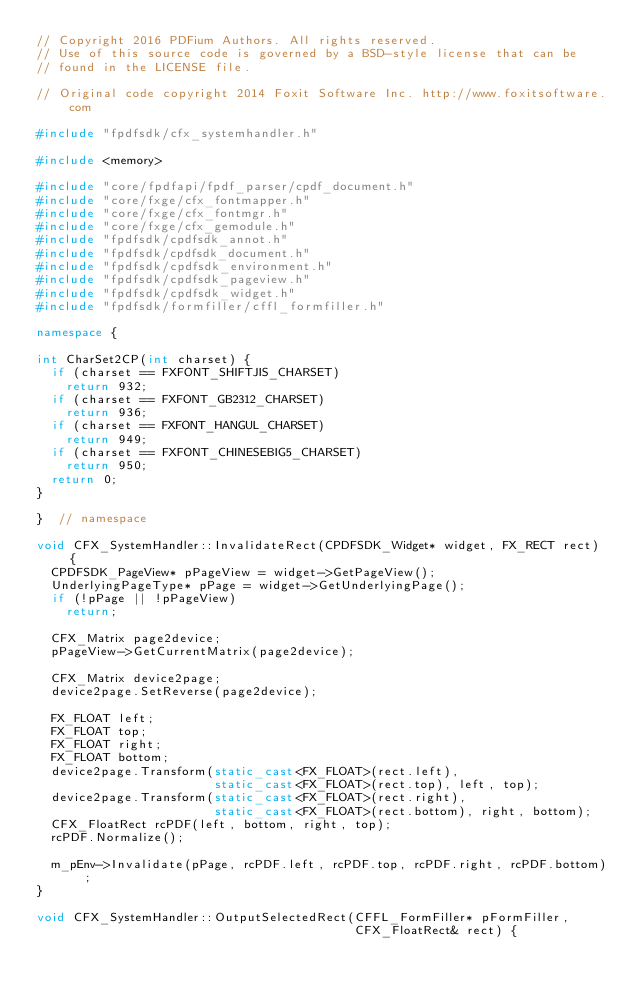<code> <loc_0><loc_0><loc_500><loc_500><_C++_>// Copyright 2016 PDFium Authors. All rights reserved.
// Use of this source code is governed by a BSD-style license that can be
// found in the LICENSE file.

// Original code copyright 2014 Foxit Software Inc. http://www.foxitsoftware.com

#include "fpdfsdk/cfx_systemhandler.h"

#include <memory>

#include "core/fpdfapi/fpdf_parser/cpdf_document.h"
#include "core/fxge/cfx_fontmapper.h"
#include "core/fxge/cfx_fontmgr.h"
#include "core/fxge/cfx_gemodule.h"
#include "fpdfsdk/cpdfsdk_annot.h"
#include "fpdfsdk/cpdfsdk_document.h"
#include "fpdfsdk/cpdfsdk_environment.h"
#include "fpdfsdk/cpdfsdk_pageview.h"
#include "fpdfsdk/cpdfsdk_widget.h"
#include "fpdfsdk/formfiller/cffl_formfiller.h"

namespace {

int CharSet2CP(int charset) {
  if (charset == FXFONT_SHIFTJIS_CHARSET)
    return 932;
  if (charset == FXFONT_GB2312_CHARSET)
    return 936;
  if (charset == FXFONT_HANGUL_CHARSET)
    return 949;
  if (charset == FXFONT_CHINESEBIG5_CHARSET)
    return 950;
  return 0;
}

}  // namespace

void CFX_SystemHandler::InvalidateRect(CPDFSDK_Widget* widget, FX_RECT rect) {
  CPDFSDK_PageView* pPageView = widget->GetPageView();
  UnderlyingPageType* pPage = widget->GetUnderlyingPage();
  if (!pPage || !pPageView)
    return;

  CFX_Matrix page2device;
  pPageView->GetCurrentMatrix(page2device);

  CFX_Matrix device2page;
  device2page.SetReverse(page2device);

  FX_FLOAT left;
  FX_FLOAT top;
  FX_FLOAT right;
  FX_FLOAT bottom;
  device2page.Transform(static_cast<FX_FLOAT>(rect.left),
                        static_cast<FX_FLOAT>(rect.top), left, top);
  device2page.Transform(static_cast<FX_FLOAT>(rect.right),
                        static_cast<FX_FLOAT>(rect.bottom), right, bottom);
  CFX_FloatRect rcPDF(left, bottom, right, top);
  rcPDF.Normalize();

  m_pEnv->Invalidate(pPage, rcPDF.left, rcPDF.top, rcPDF.right, rcPDF.bottom);
}

void CFX_SystemHandler::OutputSelectedRect(CFFL_FormFiller* pFormFiller,
                                           CFX_FloatRect& rect) {</code> 